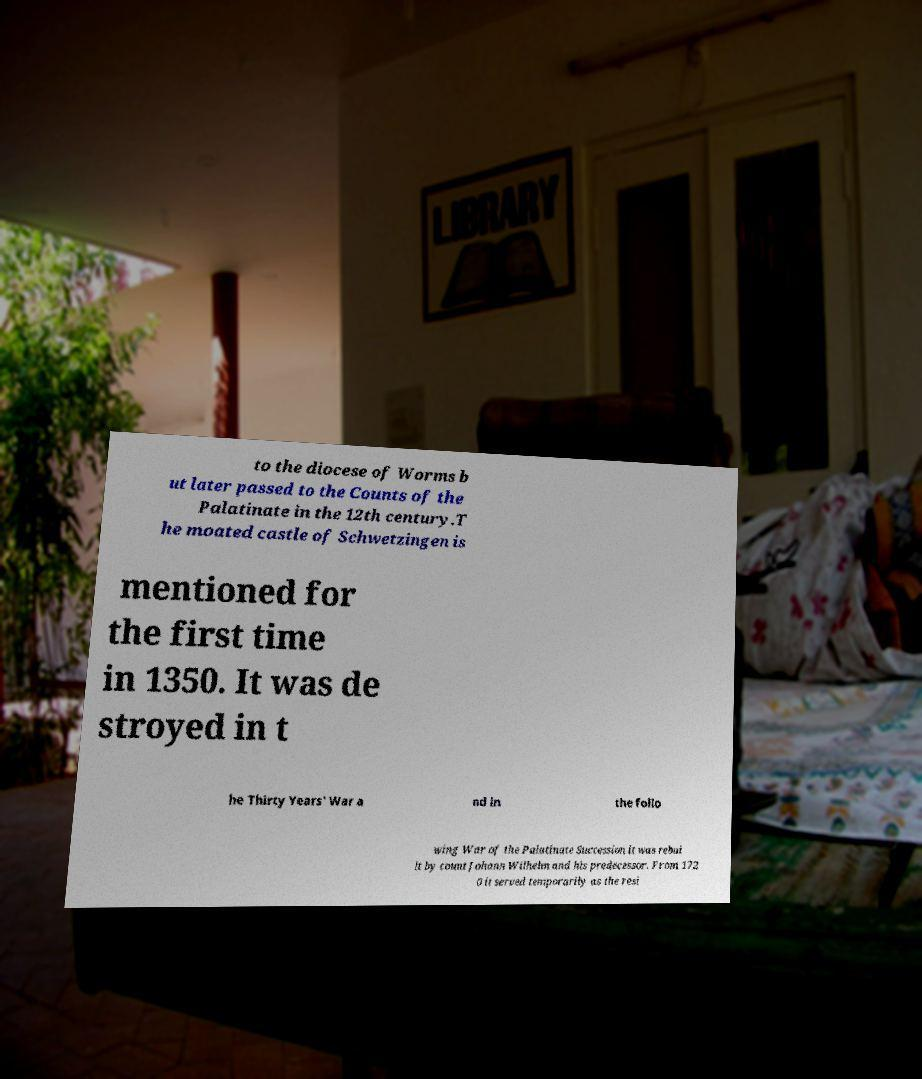I need the written content from this picture converted into text. Can you do that? to the diocese of Worms b ut later passed to the Counts of the Palatinate in the 12th century.T he moated castle of Schwetzingen is mentioned for the first time in 1350. It was de stroyed in t he Thirty Years' War a nd in the follo wing War of the Palatinate Succession it was rebui lt by count Johann Wilhelm and his predecessor. From 172 0 it served temporarily as the resi 